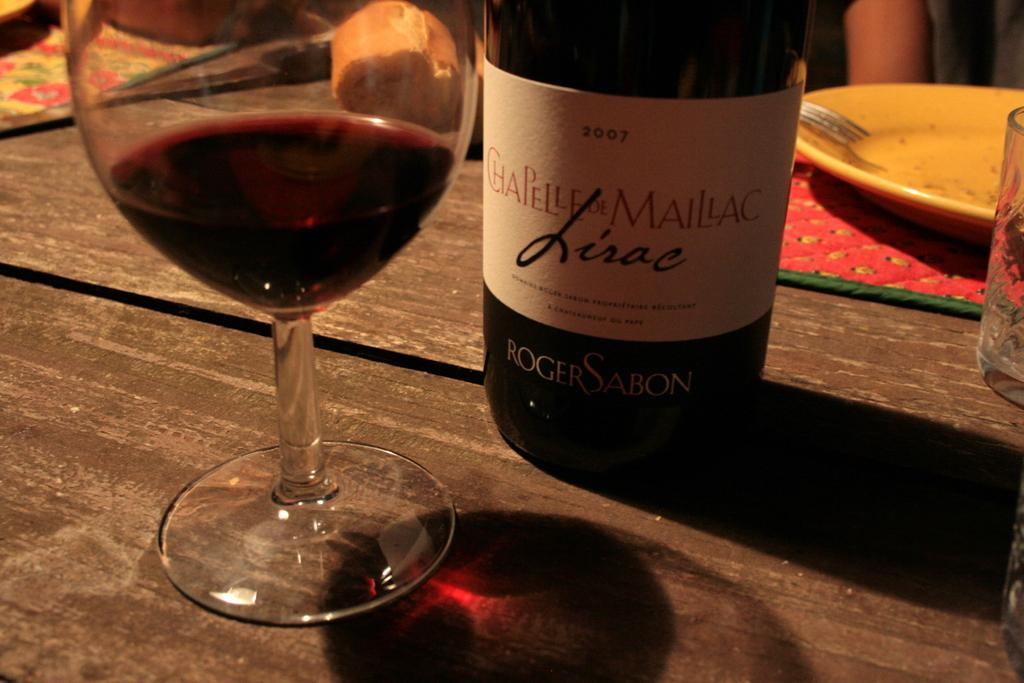Provide a one-sentence caption for the provided image. A half empty glass of red wine by Chapelle De Maillac. 